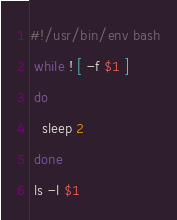Convert code to text. <code><loc_0><loc_0><loc_500><loc_500><_Bash_>#!/usr/bin/env bash
 while ! [ -f $1 ]
 do
   sleep 2
 done
 ls -l $1</code> 